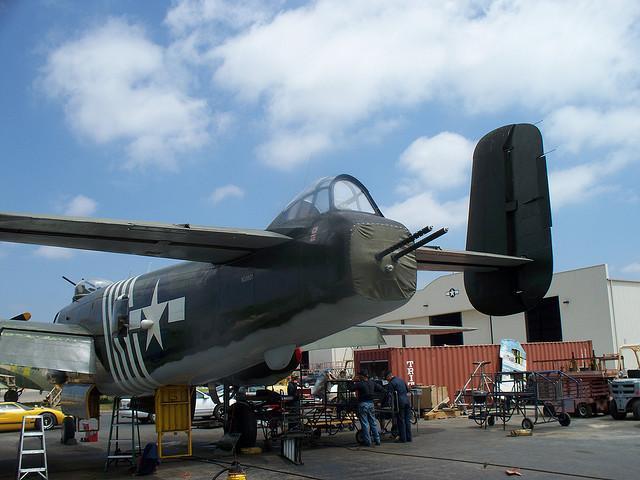How many buses are there?
Give a very brief answer. 0. 